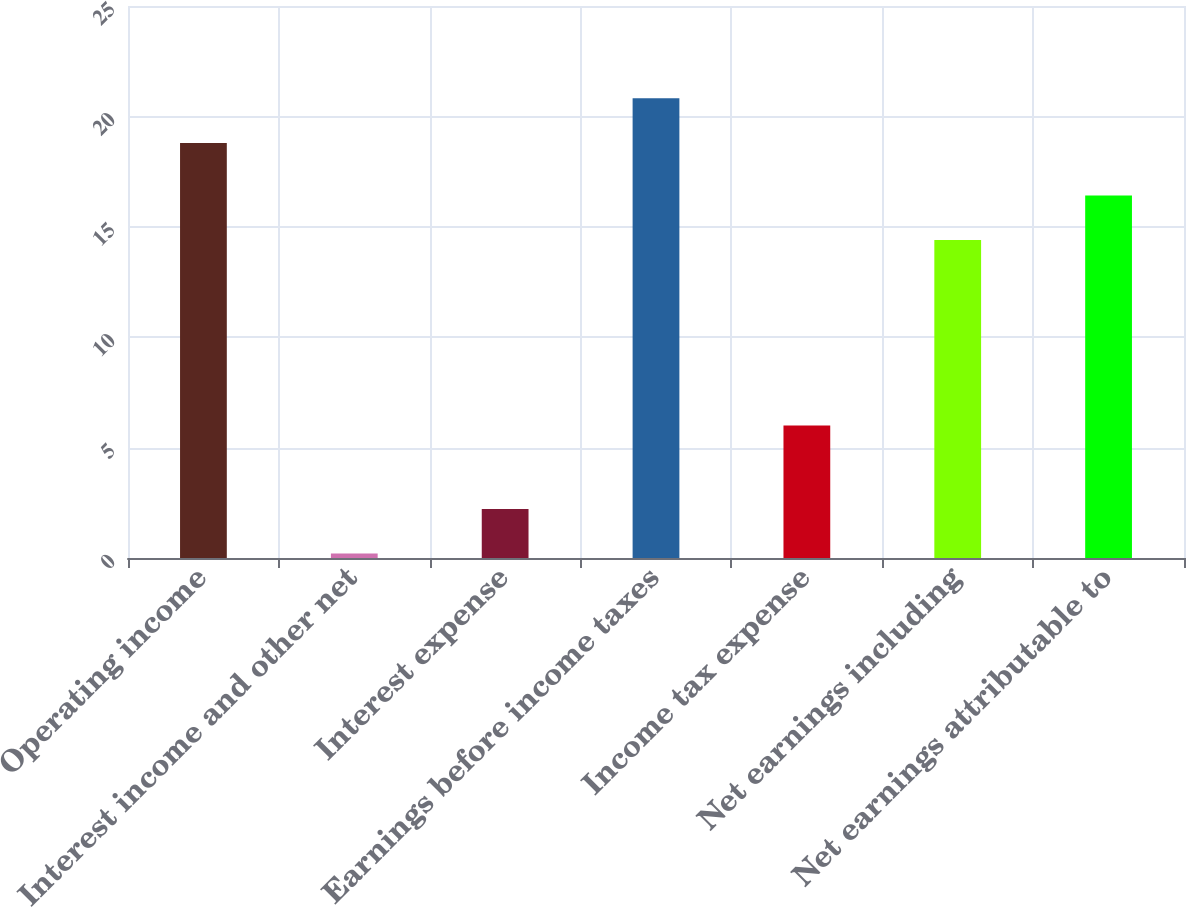Convert chart to OTSL. <chart><loc_0><loc_0><loc_500><loc_500><bar_chart><fcel>Operating income<fcel>Interest income and other net<fcel>Interest expense<fcel>Earnings before income taxes<fcel>Income tax expense<fcel>Net earnings including<fcel>Net earnings attributable to<nl><fcel>18.8<fcel>0.2<fcel>2.22<fcel>20.82<fcel>6<fcel>14.4<fcel>16.42<nl></chart> 